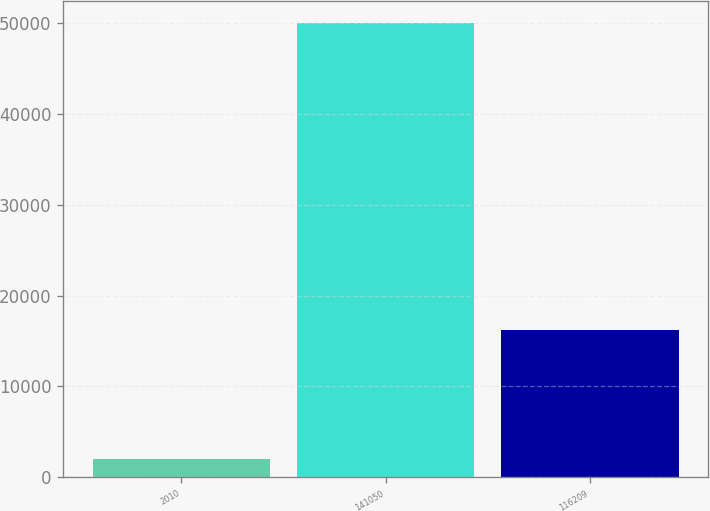Convert chart to OTSL. <chart><loc_0><loc_0><loc_500><loc_500><bar_chart><fcel>2010<fcel>141050<fcel>116209<nl><fcel>2009<fcel>50000<fcel>16209<nl></chart> 